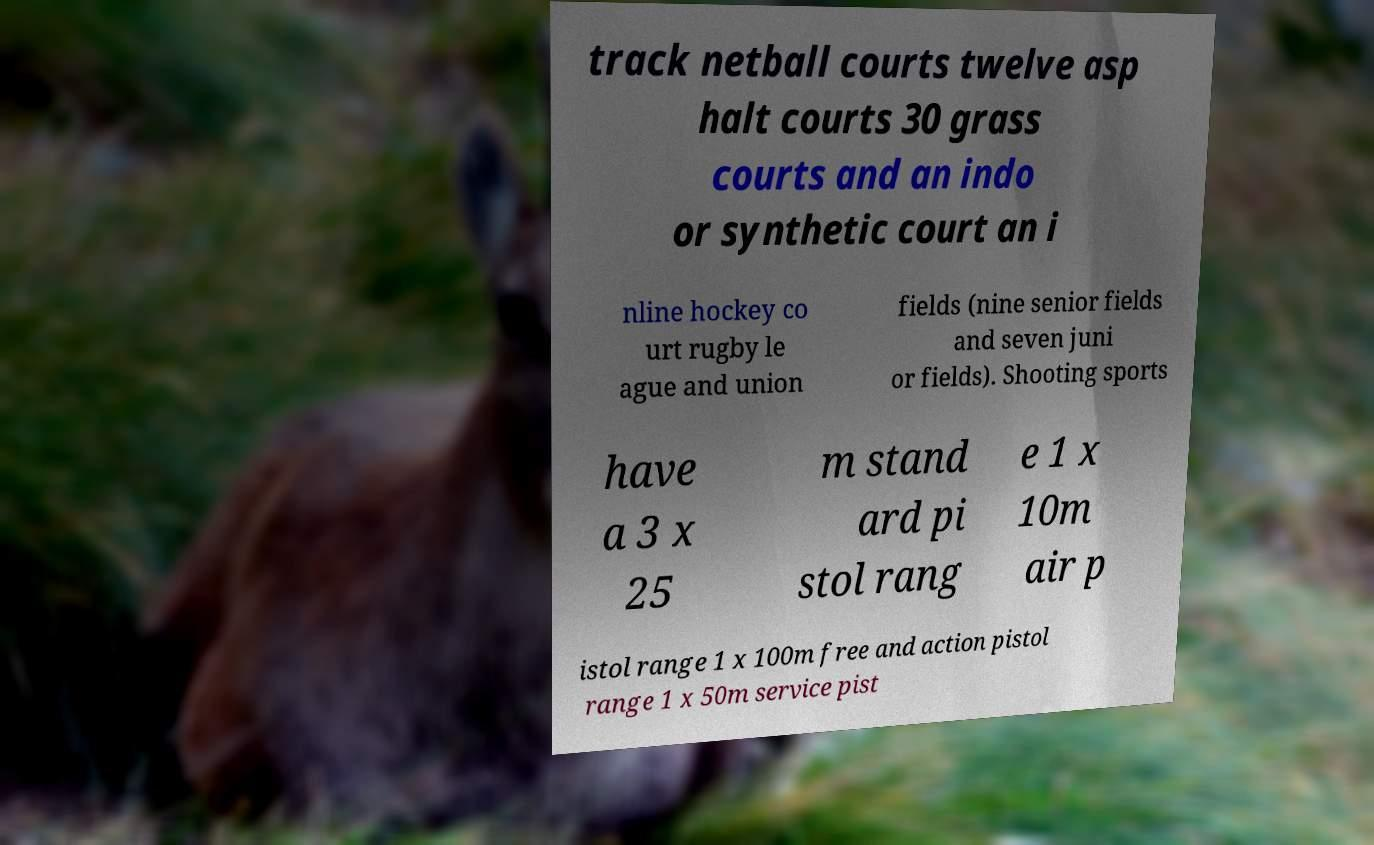Could you extract and type out the text from this image? track netball courts twelve asp halt courts 30 grass courts and an indo or synthetic court an i nline hockey co urt rugby le ague and union fields (nine senior fields and seven juni or fields). Shooting sports have a 3 x 25 m stand ard pi stol rang e 1 x 10m air p istol range 1 x 100m free and action pistol range 1 x 50m service pist 